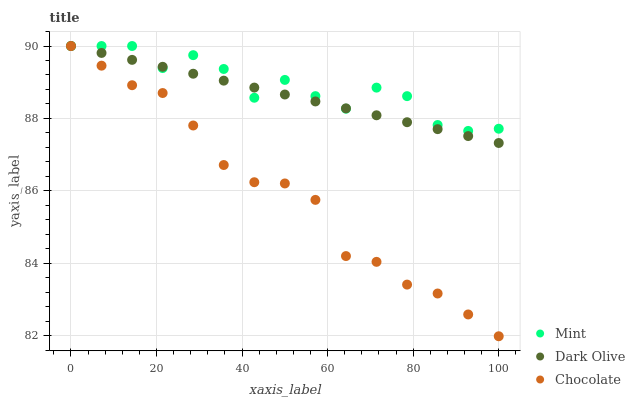Does Chocolate have the minimum area under the curve?
Answer yes or no. Yes. Does Mint have the maximum area under the curve?
Answer yes or no. Yes. Does Mint have the minimum area under the curve?
Answer yes or no. No. Does Chocolate have the maximum area under the curve?
Answer yes or no. No. Is Dark Olive the smoothest?
Answer yes or no. Yes. Is Mint the roughest?
Answer yes or no. Yes. Is Chocolate the smoothest?
Answer yes or no. No. Is Chocolate the roughest?
Answer yes or no. No. Does Chocolate have the lowest value?
Answer yes or no. Yes. Does Mint have the lowest value?
Answer yes or no. No. Does Chocolate have the highest value?
Answer yes or no. Yes. Does Mint intersect Dark Olive?
Answer yes or no. Yes. Is Mint less than Dark Olive?
Answer yes or no. No. Is Mint greater than Dark Olive?
Answer yes or no. No. 